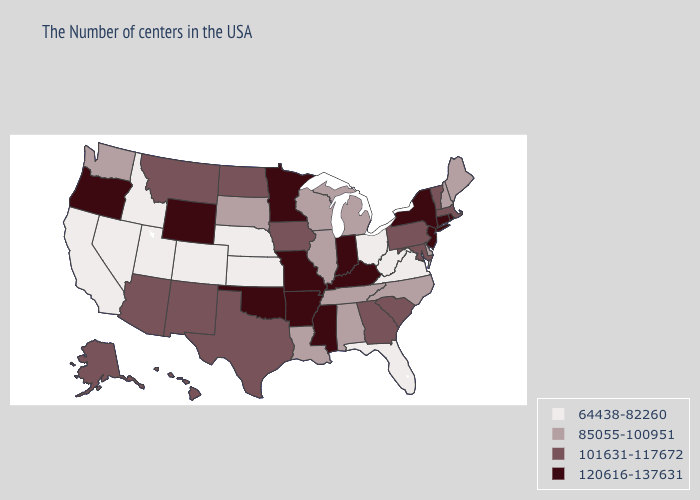Which states have the lowest value in the West?
Short answer required. Colorado, Utah, Idaho, Nevada, California. What is the lowest value in the South?
Give a very brief answer. 64438-82260. Name the states that have a value in the range 120616-137631?
Write a very short answer. Rhode Island, Connecticut, New York, New Jersey, Kentucky, Indiana, Mississippi, Missouri, Arkansas, Minnesota, Oklahoma, Wyoming, Oregon. Among the states that border Indiana , which have the lowest value?
Be succinct. Ohio. Among the states that border Idaho , does Oregon have the highest value?
Quick response, please. Yes. Does Arkansas have the lowest value in the USA?
Be succinct. No. Name the states that have a value in the range 85055-100951?
Give a very brief answer. Maine, New Hampshire, Delaware, North Carolina, Michigan, Alabama, Tennessee, Wisconsin, Illinois, Louisiana, South Dakota, Washington. Name the states that have a value in the range 120616-137631?
Be succinct. Rhode Island, Connecticut, New York, New Jersey, Kentucky, Indiana, Mississippi, Missouri, Arkansas, Minnesota, Oklahoma, Wyoming, Oregon. What is the value of Massachusetts?
Keep it brief. 101631-117672. What is the value of Michigan?
Keep it brief. 85055-100951. Does Minnesota have the same value as New Hampshire?
Be succinct. No. Does Indiana have the same value as Connecticut?
Be succinct. Yes. Does Georgia have a lower value than Utah?
Write a very short answer. No. Which states have the lowest value in the USA?
Short answer required. Virginia, West Virginia, Ohio, Florida, Kansas, Nebraska, Colorado, Utah, Idaho, Nevada, California. 